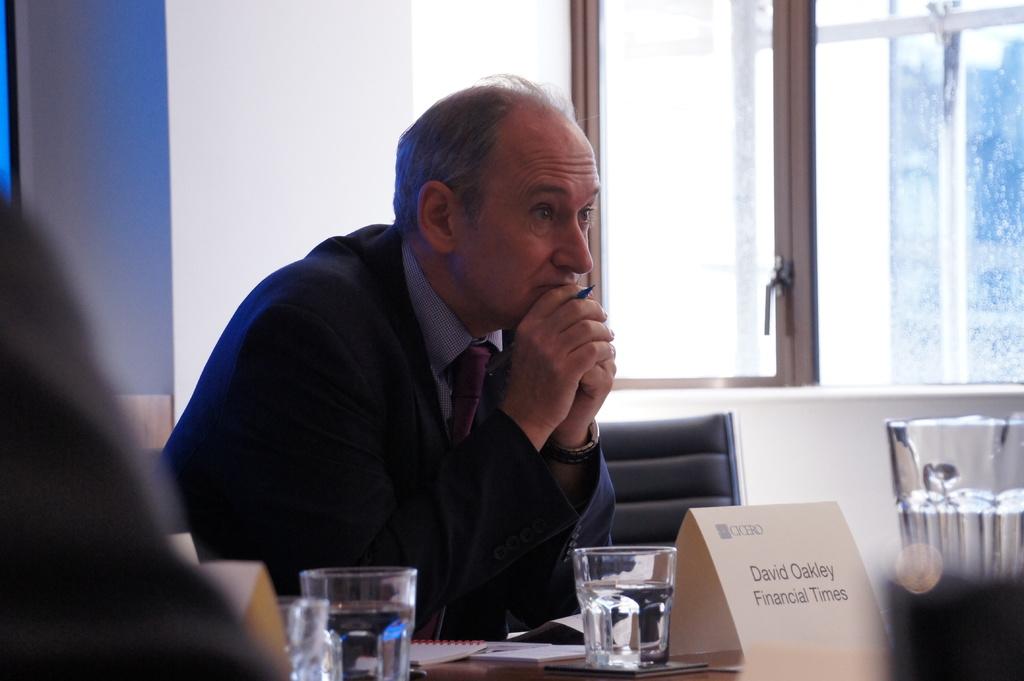Who is this?
Provide a succinct answer. David oakley. Davik oakley financial times?
Your answer should be very brief. Yes. 